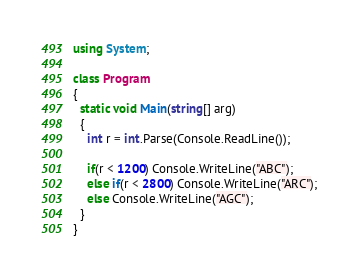<code> <loc_0><loc_0><loc_500><loc_500><_C#_>using System;

class Program
{
  static void Main(string[] arg)
  {
    int r = int.Parse(Console.ReadLine());
    
    if(r < 1200) Console.WriteLine("ABC");
    else if(r < 2800) Console.WriteLine("ARC");
    else Console.WriteLine("AGC");
  }
}</code> 